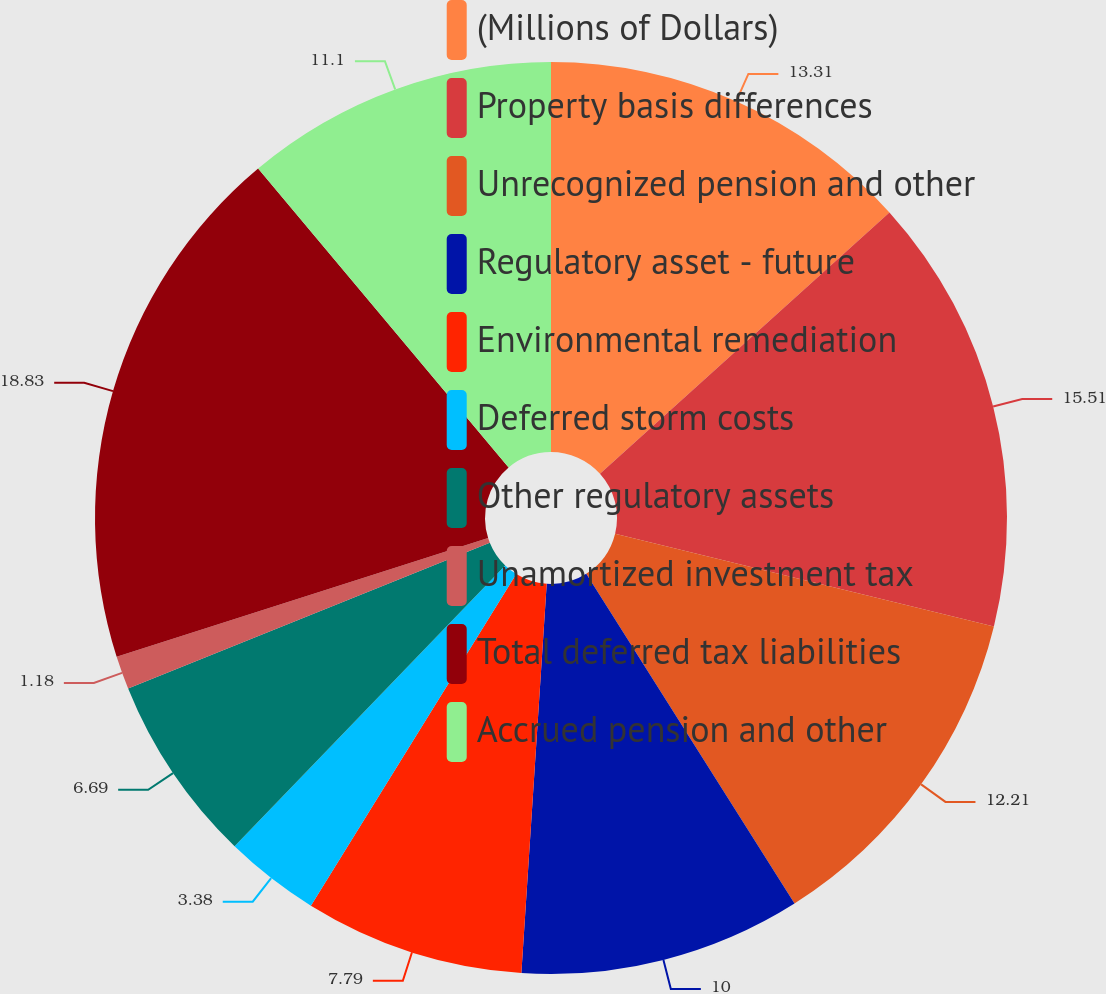<chart> <loc_0><loc_0><loc_500><loc_500><pie_chart><fcel>(Millions of Dollars)<fcel>Property basis differences<fcel>Unrecognized pension and other<fcel>Regulatory asset - future<fcel>Environmental remediation<fcel>Deferred storm costs<fcel>Other regulatory assets<fcel>Unamortized investment tax<fcel>Total deferred tax liabilities<fcel>Accrued pension and other<nl><fcel>13.31%<fcel>15.51%<fcel>12.21%<fcel>10.0%<fcel>7.79%<fcel>3.38%<fcel>6.69%<fcel>1.18%<fcel>18.82%<fcel>11.1%<nl></chart> 